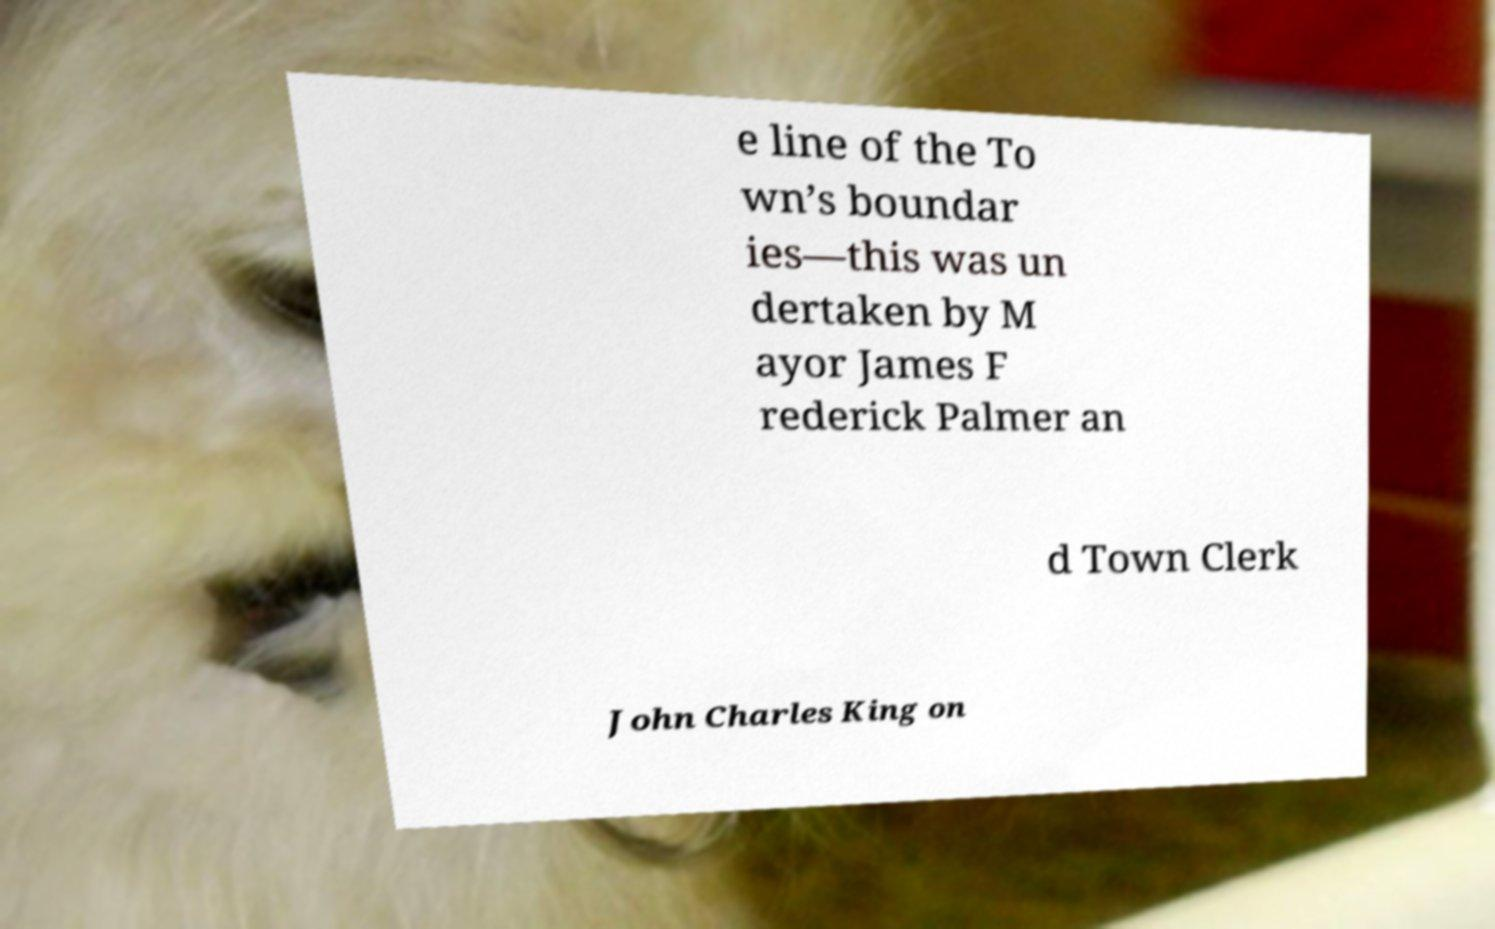Can you read and provide the text displayed in the image?This photo seems to have some interesting text. Can you extract and type it out for me? e line of the To wn’s boundar ies—this was un dertaken by M ayor James F rederick Palmer an d Town Clerk John Charles King on 